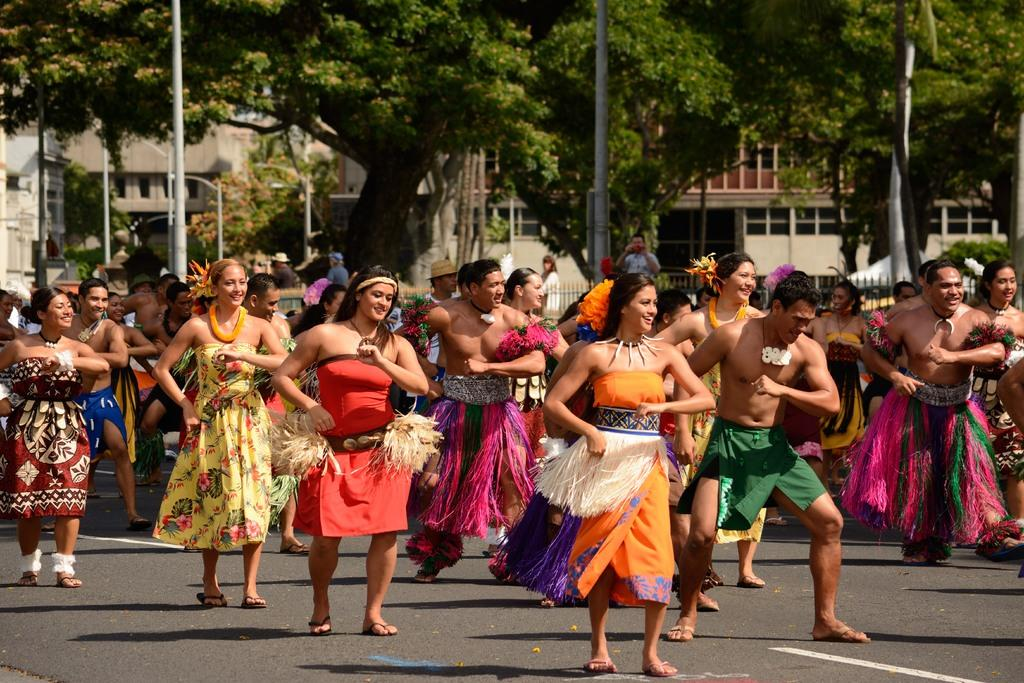What types of people are present in the image? There are men and women in the image. What are the men and women doing in the image? The men and women are standing. What can be seen in the background of the image? There are trees and buildings in the image. What type of elbow is visible in the image? There is no elbow present in the image. What news event is being discussed by the people in the image? There is no indication of a news event being discussed in the image. 